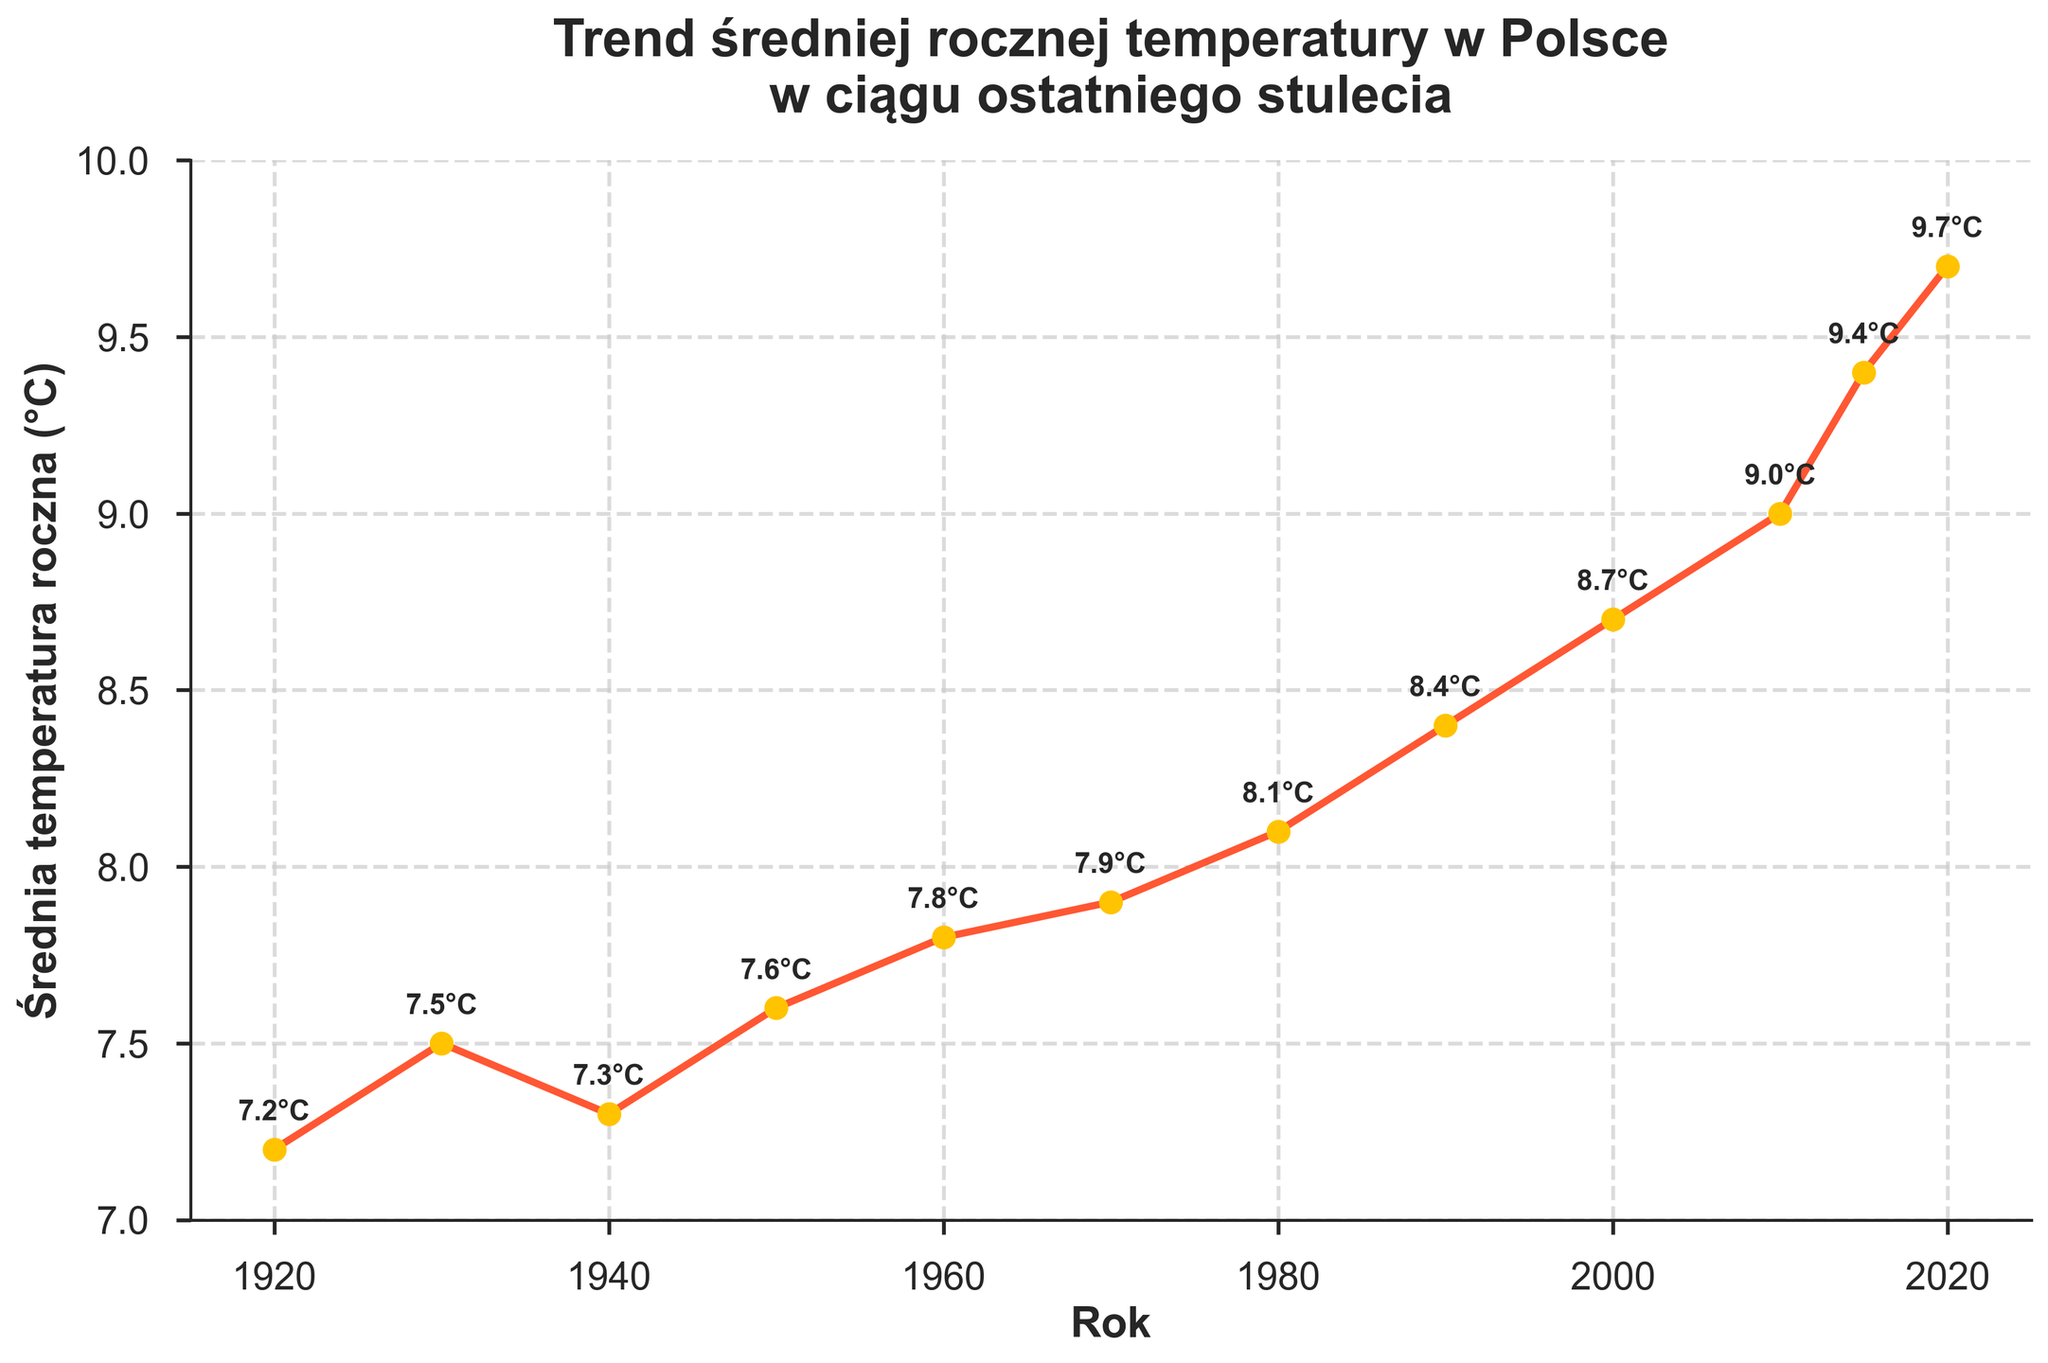What is the highest average annual temperature recorded in the past century? Look at the y-axis (Average Temperature in °C) and find the highest point on the plot. This occurs in the year 2020.
Answer: 9.7°C What is the trend of the average annual temperature over the past century? Analyze the slope of the line connecting all the data points. The line generally trends upwards from 7.2°C in 1920 to 9.7°C in 2020.
Answer: Increasing In which decade did the average annual temperature exceed 9°C for the first time? Locate the year markers along the x-axis and check the corresponding temperature for each decade. The temperature exceeds 9°C in 2010.
Answer: 2010s How much did the average annual temperature increase from the 1930s to the 2020s? Find the data points for 1930 and 2020, then calculate the difference: 9.7°C - 7.5°C = 2.2°C
Answer: 2.2°C Which decade experienced the largest increase in average annual temperature compared to the previous decade? Calculate the differences between consecutive decades, then identify the largest one: (9.0°C - 8.7°C = 0.3°C for 2010), (8.7°C - 8.4°C = 0.3°C for 2000), (8.4°C - 8.1°C = 0.3°C for 1990), (8.1°C - 7.9°C = 0.2°C for 1980), (7.9°C - 7.8°C = 0.1°C for 1970), etc. The largest increase is 0.4°C from 2000 to 2010.
Answer: 2000-2010 Between 1950 and 2000, how much did the average annual temperature change? Subtract the temperature in 1950 from the temperature in 2000: 8.7°C - 7.6°C = 1.1°C
Answer: 1.1°C Which year marks the beginning of a consistent upward trend in average annual temperature? Examine the plot to identify the year since when the temperature consistently rises. This starts in 1960.
Answer: 1960 